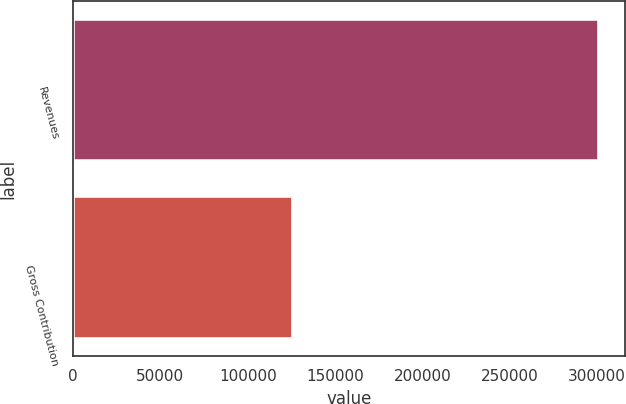<chart> <loc_0><loc_0><loc_500><loc_500><bar_chart><fcel>Revenues<fcel>Gross Contribution<nl><fcel>301074<fcel>125678<nl></chart> 